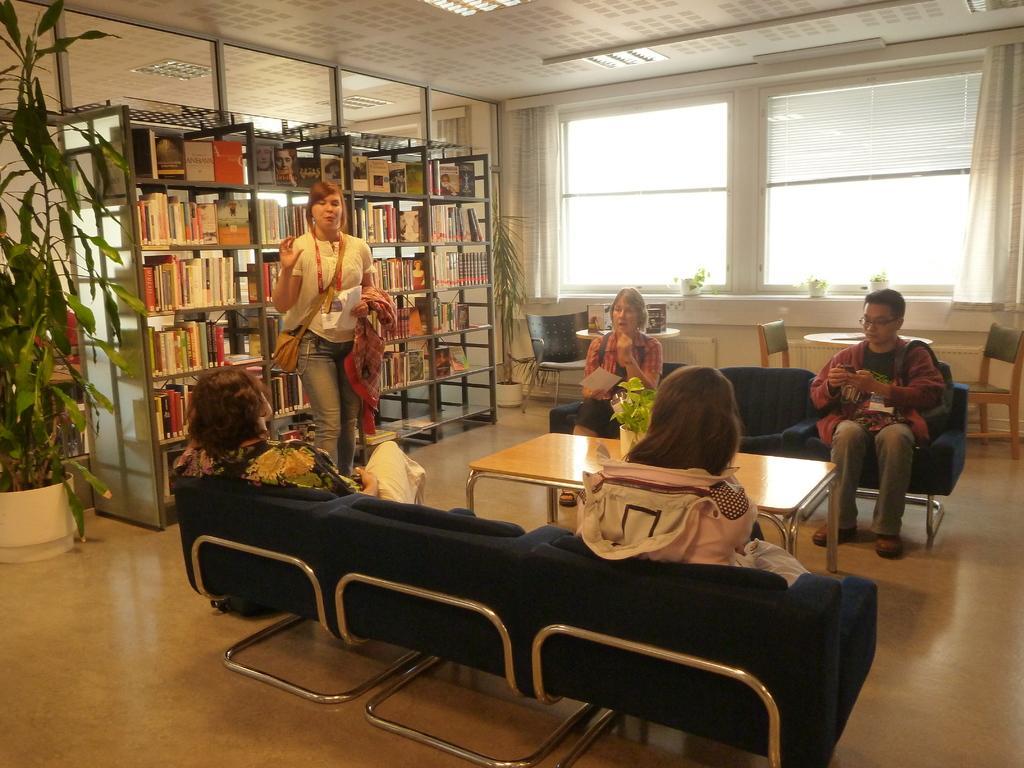In one or two sentences, can you explain what this image depicts? This picture shows few people seated on the shares and we see a woman Standing and she wore a handbag and she holds a paper in her hand and we see a bookshelf on her back and we see couple of plants and a table and curtains to the the window 